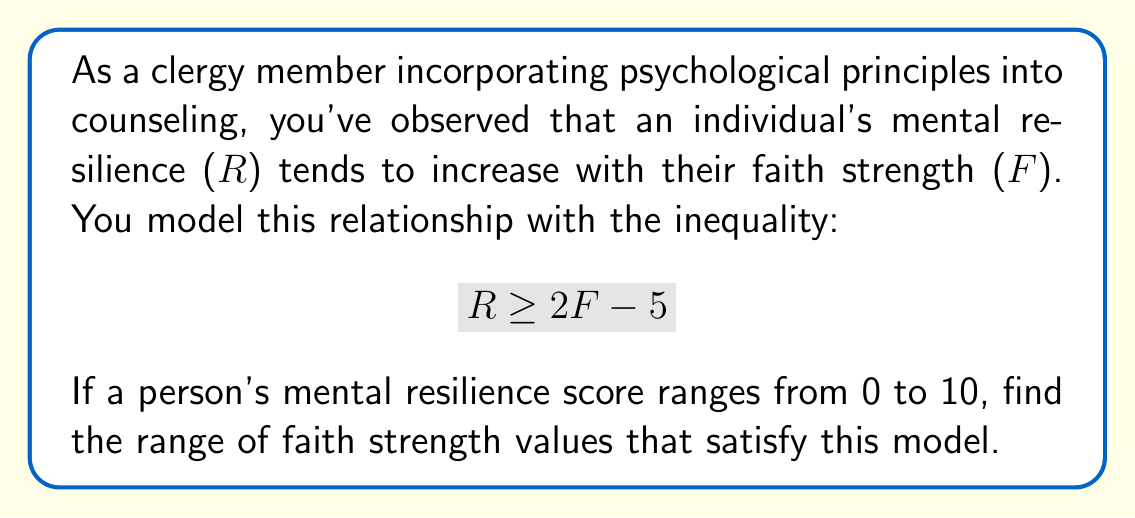Solve this math problem. To solve this problem, we'll follow these steps:

1) First, we need to consider the given constraints:
   - The relationship between R and F is modeled by $R \geq 2F - 5$
   - R ranges from 0 to 10, so $0 \leq R \leq 10$

2) Let's start with the lower bound of R:
   $0 \leq 2F - 5$
   Adding 5 to both sides:
   $5 \leq 2F$
   Dividing both sides by 2:
   $\frac{5}{2} \leq F$

3) Now, let's consider the upper bound of R:
   $2F - 5 \leq 10$
   Adding 5 to both sides:
   $2F \leq 15$
   Dividing both sides by 2:
   $F \leq \frac{15}{2}$

4) Combining the results from steps 2 and 3, we get:
   $\frac{5}{2} \leq F \leq \frac{15}{2}$

5) To express this in decimal form:
   $2.5 \leq F \leq 7.5$

This inequality represents the range of faith strength values that satisfy the model, given the constraints on mental resilience.
Answer: The solution set for faith strength (F) is:
$$ \frac{5}{2} \leq F \leq \frac{15}{2} $$ 
or in decimal form: $2.5 \leq F \leq 7.5$ 